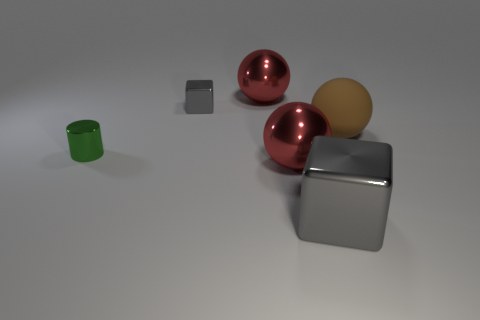Subtract all purple spheres. Subtract all brown cubes. How many spheres are left? 3 Add 2 tiny brown cylinders. How many objects exist? 8 Subtract all blocks. How many objects are left? 4 Add 2 green shiny cylinders. How many green shiny cylinders are left? 3 Add 5 small green rubber objects. How many small green rubber objects exist? 5 Subtract 0 brown cubes. How many objects are left? 6 Subtract all metal cubes. Subtract all large shiny balls. How many objects are left? 2 